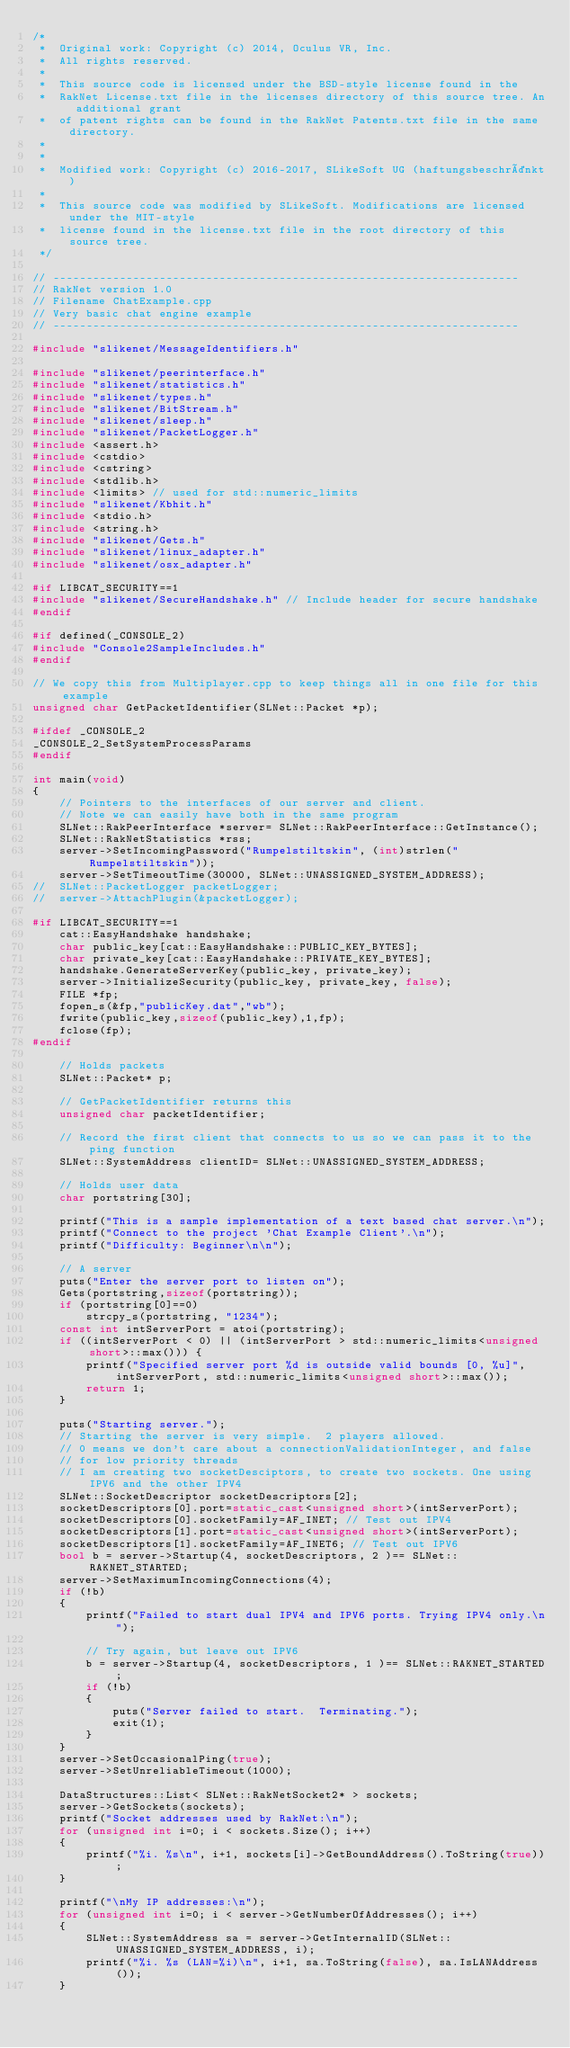<code> <loc_0><loc_0><loc_500><loc_500><_C++_>/*
 *  Original work: Copyright (c) 2014, Oculus VR, Inc.
 *  All rights reserved.
 *
 *  This source code is licensed under the BSD-style license found in the
 *  RakNet License.txt file in the licenses directory of this source tree. An additional grant 
 *  of patent rights can be found in the RakNet Patents.txt file in the same directory.
 *
 *
 *  Modified work: Copyright (c) 2016-2017, SLikeSoft UG (haftungsbeschränkt)
 *
 *  This source code was modified by SLikeSoft. Modifications are licensed under the MIT-style
 *  license found in the license.txt file in the root directory of this source tree.
 */

// ----------------------------------------------------------------------
// RakNet version 1.0
// Filename ChatExample.cpp
// Very basic chat engine example
// ----------------------------------------------------------------------

#include "slikenet/MessageIdentifiers.h"

#include "slikenet/peerinterface.h"
#include "slikenet/statistics.h"
#include "slikenet/types.h"
#include "slikenet/BitStream.h"
#include "slikenet/sleep.h"
#include "slikenet/PacketLogger.h"
#include <assert.h>
#include <cstdio>
#include <cstring>
#include <stdlib.h>
#include <limits> // used for std::numeric_limits
#include "slikenet/Kbhit.h"
#include <stdio.h>
#include <string.h>
#include "slikenet/Gets.h"
#include "slikenet/linux_adapter.h"
#include "slikenet/osx_adapter.h"

#if LIBCAT_SECURITY==1
#include "slikenet/SecureHandshake.h" // Include header for secure handshake
#endif

#if defined(_CONSOLE_2)
#include "Console2SampleIncludes.h"
#endif

// We copy this from Multiplayer.cpp to keep things all in one file for this example
unsigned char GetPacketIdentifier(SLNet::Packet *p);

#ifdef _CONSOLE_2
_CONSOLE_2_SetSystemProcessParams
#endif

int main(void)
{
	// Pointers to the interfaces of our server and client.
	// Note we can easily have both in the same program
	SLNet::RakPeerInterface *server= SLNet::RakPeerInterface::GetInstance();
	SLNet::RakNetStatistics *rss;
	server->SetIncomingPassword("Rumpelstiltskin", (int)strlen("Rumpelstiltskin"));
	server->SetTimeoutTime(30000, SLNet::UNASSIGNED_SYSTEM_ADDRESS);
//	SLNet::PacketLogger packetLogger;
//	server->AttachPlugin(&packetLogger);

#if LIBCAT_SECURITY==1
	cat::EasyHandshake handshake;
	char public_key[cat::EasyHandshake::PUBLIC_KEY_BYTES];
	char private_key[cat::EasyHandshake::PRIVATE_KEY_BYTES];
	handshake.GenerateServerKey(public_key, private_key);
	server->InitializeSecurity(public_key, private_key, false);
	FILE *fp;
	fopen_s(&fp,"publicKey.dat","wb");
	fwrite(public_key,sizeof(public_key),1,fp);
	fclose(fp);
#endif

	// Holds packets
	SLNet::Packet* p;

	// GetPacketIdentifier returns this
	unsigned char packetIdentifier;

	// Record the first client that connects to us so we can pass it to the ping function
	SLNet::SystemAddress clientID= SLNet::UNASSIGNED_SYSTEM_ADDRESS;

	// Holds user data
	char portstring[30];

	printf("This is a sample implementation of a text based chat server.\n");
	printf("Connect to the project 'Chat Example Client'.\n");
	printf("Difficulty: Beginner\n\n");

	// A server
	puts("Enter the server port to listen on");
	Gets(portstring,sizeof(portstring));
	if (portstring[0]==0)
		strcpy_s(portstring, "1234");
	const int intServerPort = atoi(portstring);
	if ((intServerPort < 0) || (intServerPort > std::numeric_limits<unsigned short>::max())) {
		printf("Specified server port %d is outside valid bounds [0, %u]", intServerPort, std::numeric_limits<unsigned short>::max());
		return 1;
	}

	puts("Starting server.");
	// Starting the server is very simple.  2 players allowed.
	// 0 means we don't care about a connectionValidationInteger, and false
	// for low priority threads
	// I am creating two socketDesciptors, to create two sockets. One using IPV6 and the other IPV4
	SLNet::SocketDescriptor socketDescriptors[2];
	socketDescriptors[0].port=static_cast<unsigned short>(intServerPort);
	socketDescriptors[0].socketFamily=AF_INET; // Test out IPV4
	socketDescriptors[1].port=static_cast<unsigned short>(intServerPort);
	socketDescriptors[1].socketFamily=AF_INET6; // Test out IPV6
	bool b = server->Startup(4, socketDescriptors, 2 )== SLNet::RAKNET_STARTED;
	server->SetMaximumIncomingConnections(4);
	if (!b)
	{
		printf("Failed to start dual IPV4 and IPV6 ports. Trying IPV4 only.\n");

		// Try again, but leave out IPV6
		b = server->Startup(4, socketDescriptors, 1 )== SLNet::RAKNET_STARTED;
		if (!b)
		{
			puts("Server failed to start.  Terminating.");
			exit(1);
		}
	}
	server->SetOccasionalPing(true);
	server->SetUnreliableTimeout(1000);

	DataStructures::List< SLNet::RakNetSocket2* > sockets;
	server->GetSockets(sockets);
	printf("Socket addresses used by RakNet:\n");
	for (unsigned int i=0; i < sockets.Size(); i++)
	{
		printf("%i. %s\n", i+1, sockets[i]->GetBoundAddress().ToString(true));
	}

	printf("\nMy IP addresses:\n");
	for (unsigned int i=0; i < server->GetNumberOfAddresses(); i++)
	{
		SLNet::SystemAddress sa = server->GetInternalID(SLNet::UNASSIGNED_SYSTEM_ADDRESS, i);
		printf("%i. %s (LAN=%i)\n", i+1, sa.ToString(false), sa.IsLANAddress());
	}
</code> 